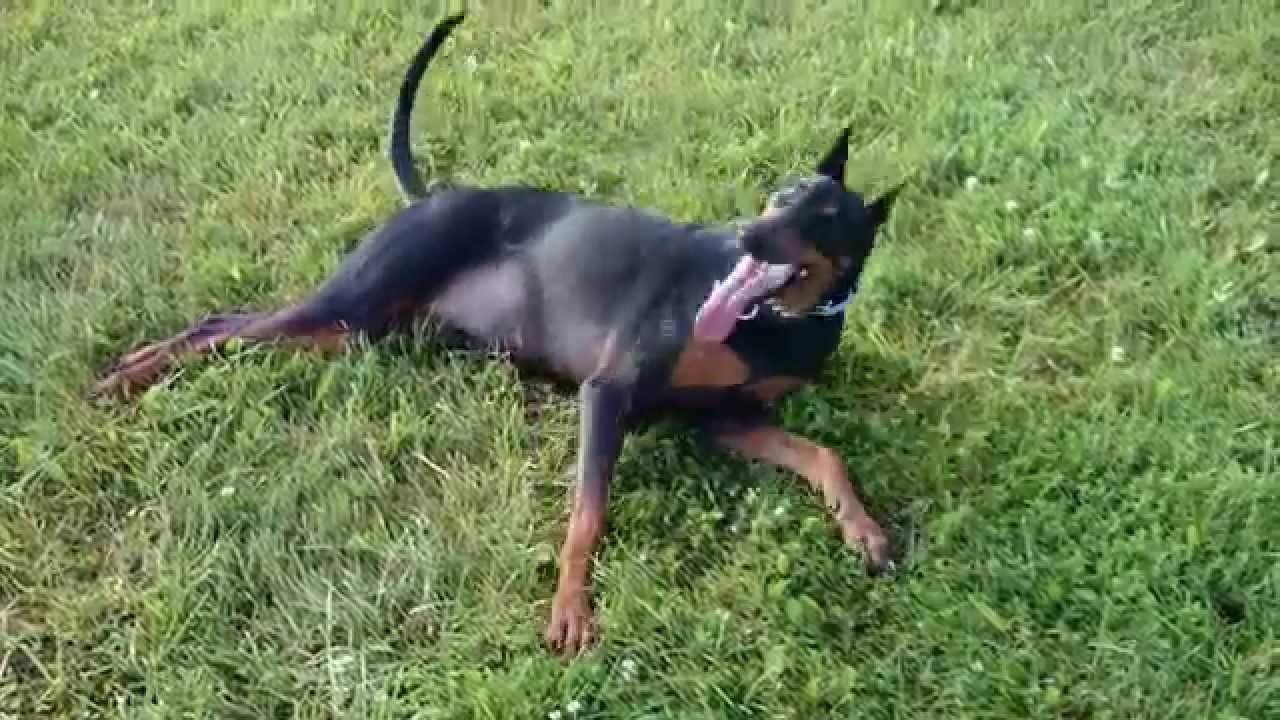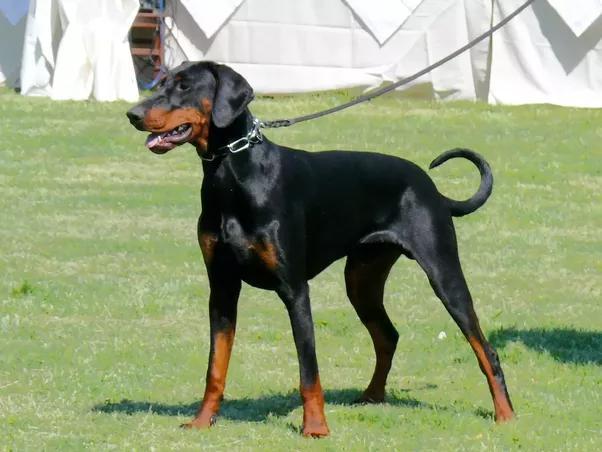The first image is the image on the left, the second image is the image on the right. Considering the images on both sides, is "The left image shows a floppy-eared doberman standing with its undocked tail curled upward, and the right image shows a doberman with pointy erect ears and a docked tail who is standing up." valid? Answer yes or no. No. The first image is the image on the left, the second image is the image on the right. Assess this claim about the two images: "One dog's tail is docked; the other dog's tail is normal.". Correct or not? Answer yes or no. No. 